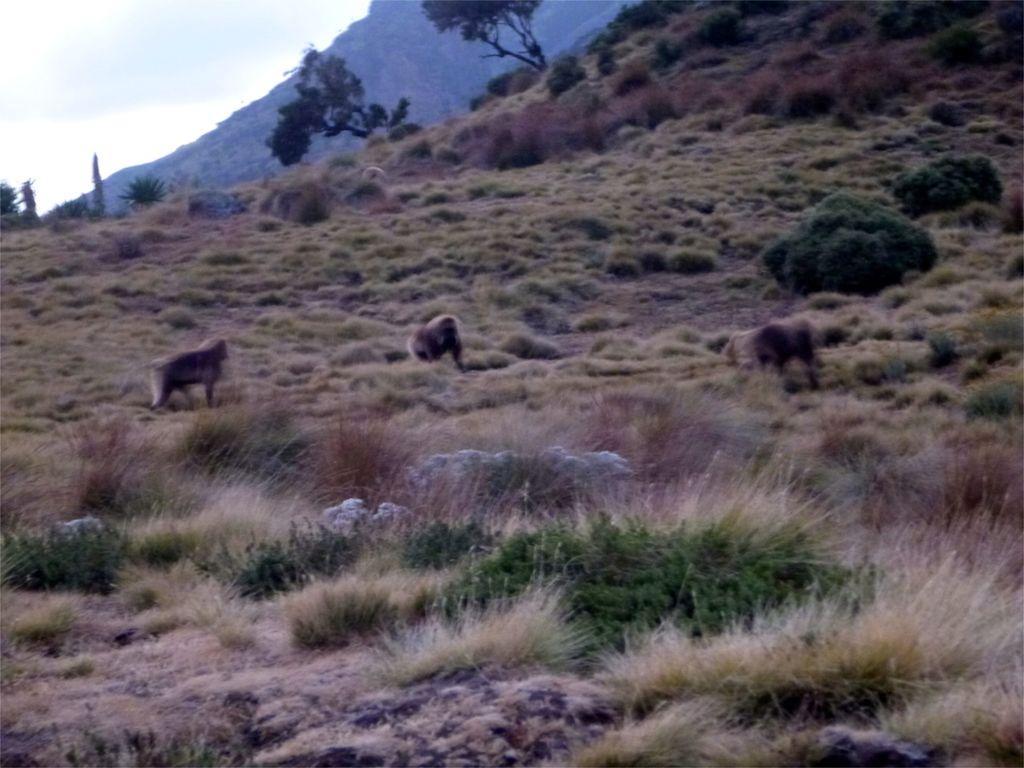Could you give a brief overview of what you see in this image? In the foreground I can see three monkeys on the grass, trees and mountains. In the top left I can see the sky. This image is taken may be near the hill station. 